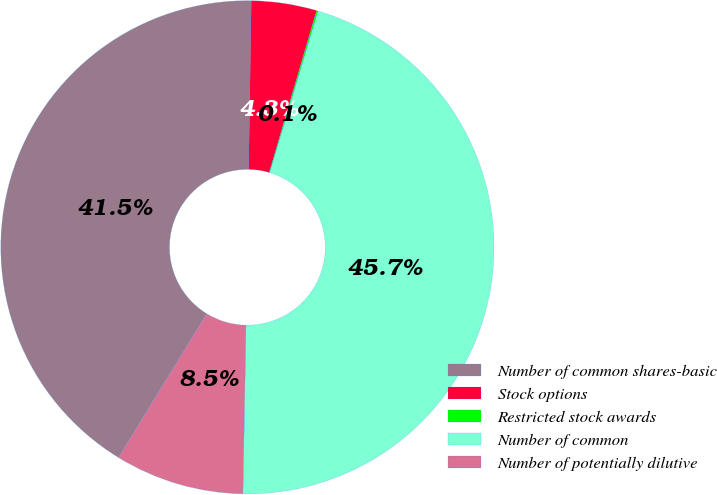<chart> <loc_0><loc_0><loc_500><loc_500><pie_chart><fcel>Number of common shares-basic<fcel>Stock options<fcel>Restricted stock awards<fcel>Number of common<fcel>Number of potentially dilutive<nl><fcel>41.49%<fcel>4.28%<fcel>0.1%<fcel>45.66%<fcel>8.46%<nl></chart> 